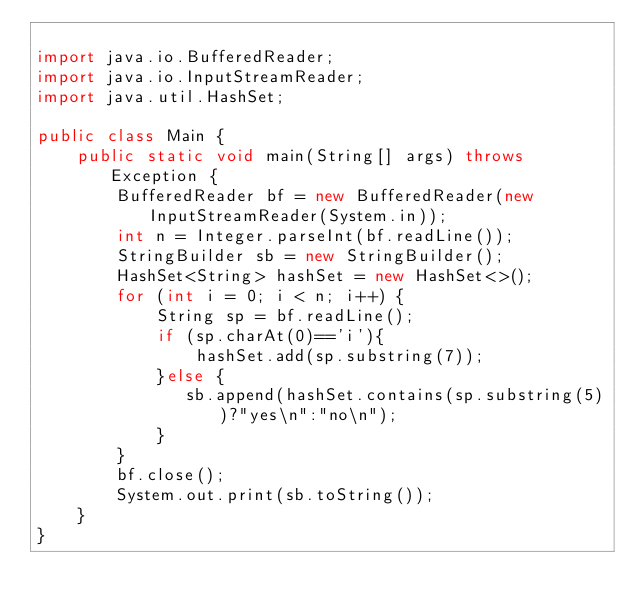Convert code to text. <code><loc_0><loc_0><loc_500><loc_500><_Java_>
import java.io.BufferedReader;
import java.io.InputStreamReader;
import java.util.HashSet;

public class Main {
    public static void main(String[] args) throws Exception {
        BufferedReader bf = new BufferedReader(new InputStreamReader(System.in));
        int n = Integer.parseInt(bf.readLine());
        StringBuilder sb = new StringBuilder();
        HashSet<String> hashSet = new HashSet<>();
        for (int i = 0; i < n; i++) {
            String sp = bf.readLine();
            if (sp.charAt(0)=='i'){
                hashSet.add(sp.substring(7));
            }else {
               sb.append(hashSet.contains(sp.substring(5))?"yes\n":"no\n");
            }
        }
        bf.close();
        System.out.print(sb.toString());
    }
}
</code> 